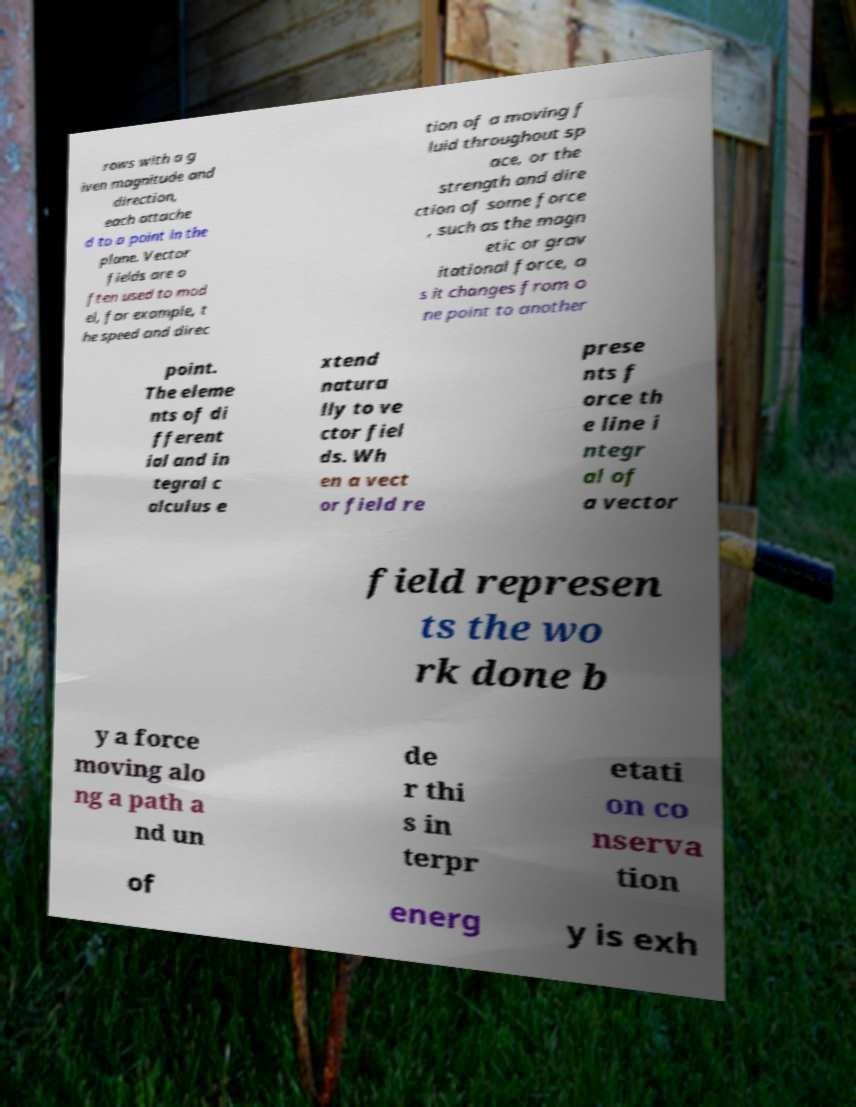Please read and relay the text visible in this image. What does it say? rows with a g iven magnitude and direction, each attache d to a point in the plane. Vector fields are o ften used to mod el, for example, t he speed and direc tion of a moving f luid throughout sp ace, or the strength and dire ction of some force , such as the magn etic or grav itational force, a s it changes from o ne point to another point. The eleme nts of di fferent ial and in tegral c alculus e xtend natura lly to ve ctor fiel ds. Wh en a vect or field re prese nts f orce th e line i ntegr al of a vector field represen ts the wo rk done b y a force moving alo ng a path a nd un de r thi s in terpr etati on co nserva tion of energ y is exh 